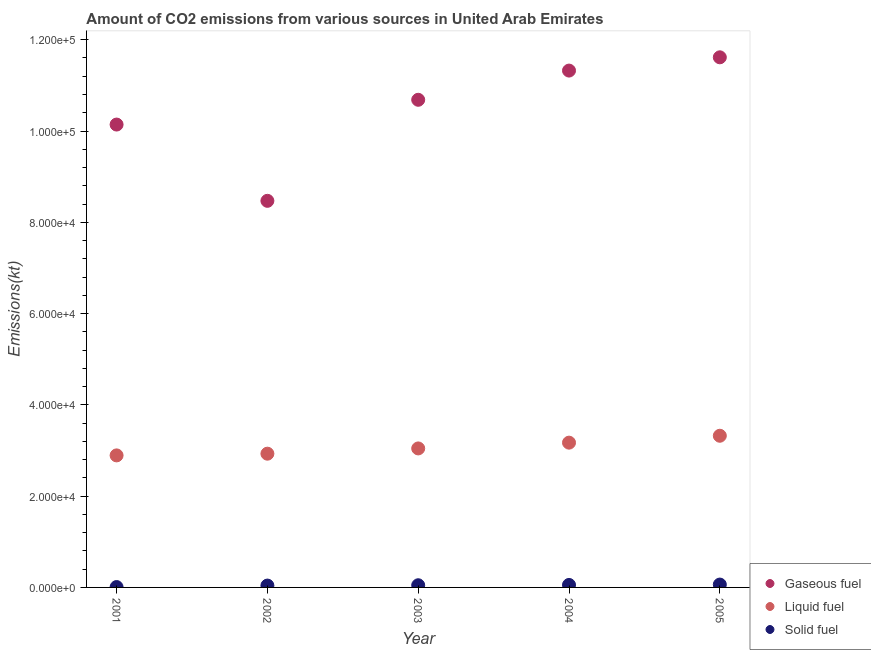What is the amount of co2 emissions from solid fuel in 2002?
Give a very brief answer. 407.04. Across all years, what is the maximum amount of co2 emissions from solid fuel?
Make the answer very short. 627.06. Across all years, what is the minimum amount of co2 emissions from liquid fuel?
Make the answer very short. 2.89e+04. What is the total amount of co2 emissions from liquid fuel in the graph?
Your answer should be very brief. 1.54e+05. What is the difference between the amount of co2 emissions from solid fuel in 2002 and that in 2004?
Make the answer very short. -135.68. What is the difference between the amount of co2 emissions from solid fuel in 2001 and the amount of co2 emissions from gaseous fuel in 2004?
Provide a succinct answer. -1.13e+05. What is the average amount of co2 emissions from liquid fuel per year?
Ensure brevity in your answer.  3.07e+04. In the year 2003, what is the difference between the amount of co2 emissions from gaseous fuel and amount of co2 emissions from liquid fuel?
Provide a short and direct response. 7.64e+04. What is the ratio of the amount of co2 emissions from gaseous fuel in 2003 to that in 2005?
Your response must be concise. 0.92. Is the amount of co2 emissions from liquid fuel in 2001 less than that in 2005?
Give a very brief answer. Yes. Is the difference between the amount of co2 emissions from gaseous fuel in 2001 and 2003 greater than the difference between the amount of co2 emissions from liquid fuel in 2001 and 2003?
Ensure brevity in your answer.  No. What is the difference between the highest and the second highest amount of co2 emissions from gaseous fuel?
Make the answer very short. 2907.93. What is the difference between the highest and the lowest amount of co2 emissions from solid fuel?
Keep it short and to the point. 546.38. In how many years, is the amount of co2 emissions from solid fuel greater than the average amount of co2 emissions from solid fuel taken over all years?
Provide a succinct answer. 3. Does the amount of co2 emissions from liquid fuel monotonically increase over the years?
Offer a terse response. Yes. Is the amount of co2 emissions from gaseous fuel strictly greater than the amount of co2 emissions from liquid fuel over the years?
Offer a very short reply. Yes. Is the amount of co2 emissions from gaseous fuel strictly less than the amount of co2 emissions from liquid fuel over the years?
Provide a short and direct response. No. What is the difference between two consecutive major ticks on the Y-axis?
Provide a succinct answer. 2.00e+04. Does the graph contain grids?
Ensure brevity in your answer.  No. Where does the legend appear in the graph?
Provide a succinct answer. Bottom right. How many legend labels are there?
Provide a succinct answer. 3. How are the legend labels stacked?
Keep it short and to the point. Vertical. What is the title of the graph?
Ensure brevity in your answer.  Amount of CO2 emissions from various sources in United Arab Emirates. Does "Natural gas sources" appear as one of the legend labels in the graph?
Give a very brief answer. No. What is the label or title of the Y-axis?
Your answer should be compact. Emissions(kt). What is the Emissions(kt) of Gaseous fuel in 2001?
Keep it short and to the point. 1.01e+05. What is the Emissions(kt) in Liquid fuel in 2001?
Your answer should be very brief. 2.89e+04. What is the Emissions(kt) of Solid fuel in 2001?
Provide a succinct answer. 80.67. What is the Emissions(kt) of Gaseous fuel in 2002?
Your answer should be compact. 8.47e+04. What is the Emissions(kt) of Liquid fuel in 2002?
Provide a succinct answer. 2.93e+04. What is the Emissions(kt) of Solid fuel in 2002?
Keep it short and to the point. 407.04. What is the Emissions(kt) of Gaseous fuel in 2003?
Offer a terse response. 1.07e+05. What is the Emissions(kt) in Liquid fuel in 2003?
Your answer should be compact. 3.05e+04. What is the Emissions(kt) in Solid fuel in 2003?
Make the answer very short. 476.71. What is the Emissions(kt) in Gaseous fuel in 2004?
Give a very brief answer. 1.13e+05. What is the Emissions(kt) in Liquid fuel in 2004?
Ensure brevity in your answer.  3.17e+04. What is the Emissions(kt) of Solid fuel in 2004?
Ensure brevity in your answer.  542.72. What is the Emissions(kt) in Gaseous fuel in 2005?
Offer a terse response. 1.16e+05. What is the Emissions(kt) of Liquid fuel in 2005?
Your answer should be very brief. 3.32e+04. What is the Emissions(kt) of Solid fuel in 2005?
Give a very brief answer. 627.06. Across all years, what is the maximum Emissions(kt) of Gaseous fuel?
Keep it short and to the point. 1.16e+05. Across all years, what is the maximum Emissions(kt) of Liquid fuel?
Your answer should be compact. 3.32e+04. Across all years, what is the maximum Emissions(kt) of Solid fuel?
Your answer should be compact. 627.06. Across all years, what is the minimum Emissions(kt) in Gaseous fuel?
Your response must be concise. 8.47e+04. Across all years, what is the minimum Emissions(kt) in Liquid fuel?
Give a very brief answer. 2.89e+04. Across all years, what is the minimum Emissions(kt) in Solid fuel?
Make the answer very short. 80.67. What is the total Emissions(kt) in Gaseous fuel in the graph?
Your answer should be compact. 5.22e+05. What is the total Emissions(kt) of Liquid fuel in the graph?
Provide a succinct answer. 1.54e+05. What is the total Emissions(kt) of Solid fuel in the graph?
Keep it short and to the point. 2134.19. What is the difference between the Emissions(kt) of Gaseous fuel in 2001 and that in 2002?
Give a very brief answer. 1.67e+04. What is the difference between the Emissions(kt) in Liquid fuel in 2001 and that in 2002?
Your response must be concise. -374.03. What is the difference between the Emissions(kt) in Solid fuel in 2001 and that in 2002?
Your response must be concise. -326.36. What is the difference between the Emissions(kt) of Gaseous fuel in 2001 and that in 2003?
Your answer should be very brief. -5427.16. What is the difference between the Emissions(kt) of Liquid fuel in 2001 and that in 2003?
Ensure brevity in your answer.  -1525.47. What is the difference between the Emissions(kt) in Solid fuel in 2001 and that in 2003?
Keep it short and to the point. -396.04. What is the difference between the Emissions(kt) of Gaseous fuel in 2001 and that in 2004?
Offer a very short reply. -1.18e+04. What is the difference between the Emissions(kt) in Liquid fuel in 2001 and that in 2004?
Your response must be concise. -2790.59. What is the difference between the Emissions(kt) in Solid fuel in 2001 and that in 2004?
Your answer should be very brief. -462.04. What is the difference between the Emissions(kt) in Gaseous fuel in 2001 and that in 2005?
Make the answer very short. -1.47e+04. What is the difference between the Emissions(kt) in Liquid fuel in 2001 and that in 2005?
Provide a succinct answer. -4301.39. What is the difference between the Emissions(kt) of Solid fuel in 2001 and that in 2005?
Your answer should be compact. -546.38. What is the difference between the Emissions(kt) of Gaseous fuel in 2002 and that in 2003?
Offer a very short reply. -2.21e+04. What is the difference between the Emissions(kt) of Liquid fuel in 2002 and that in 2003?
Your response must be concise. -1151.44. What is the difference between the Emissions(kt) of Solid fuel in 2002 and that in 2003?
Make the answer very short. -69.67. What is the difference between the Emissions(kt) of Gaseous fuel in 2002 and that in 2004?
Offer a terse response. -2.85e+04. What is the difference between the Emissions(kt) in Liquid fuel in 2002 and that in 2004?
Your response must be concise. -2416.55. What is the difference between the Emissions(kt) in Solid fuel in 2002 and that in 2004?
Offer a very short reply. -135.68. What is the difference between the Emissions(kt) of Gaseous fuel in 2002 and that in 2005?
Offer a terse response. -3.14e+04. What is the difference between the Emissions(kt) in Liquid fuel in 2002 and that in 2005?
Give a very brief answer. -3927.36. What is the difference between the Emissions(kt) in Solid fuel in 2002 and that in 2005?
Your answer should be compact. -220.02. What is the difference between the Emissions(kt) of Gaseous fuel in 2003 and that in 2004?
Keep it short and to the point. -6398.91. What is the difference between the Emissions(kt) of Liquid fuel in 2003 and that in 2004?
Provide a short and direct response. -1265.12. What is the difference between the Emissions(kt) of Solid fuel in 2003 and that in 2004?
Provide a short and direct response. -66.01. What is the difference between the Emissions(kt) in Gaseous fuel in 2003 and that in 2005?
Keep it short and to the point. -9306.85. What is the difference between the Emissions(kt) in Liquid fuel in 2003 and that in 2005?
Offer a very short reply. -2775.92. What is the difference between the Emissions(kt) of Solid fuel in 2003 and that in 2005?
Offer a very short reply. -150.35. What is the difference between the Emissions(kt) in Gaseous fuel in 2004 and that in 2005?
Ensure brevity in your answer.  -2907.93. What is the difference between the Emissions(kt) in Liquid fuel in 2004 and that in 2005?
Keep it short and to the point. -1510.8. What is the difference between the Emissions(kt) in Solid fuel in 2004 and that in 2005?
Offer a very short reply. -84.34. What is the difference between the Emissions(kt) of Gaseous fuel in 2001 and the Emissions(kt) of Liquid fuel in 2002?
Offer a very short reply. 7.21e+04. What is the difference between the Emissions(kt) of Gaseous fuel in 2001 and the Emissions(kt) of Solid fuel in 2002?
Your response must be concise. 1.01e+05. What is the difference between the Emissions(kt) in Liquid fuel in 2001 and the Emissions(kt) in Solid fuel in 2002?
Make the answer very short. 2.85e+04. What is the difference between the Emissions(kt) of Gaseous fuel in 2001 and the Emissions(kt) of Liquid fuel in 2003?
Offer a very short reply. 7.10e+04. What is the difference between the Emissions(kt) in Gaseous fuel in 2001 and the Emissions(kt) in Solid fuel in 2003?
Make the answer very short. 1.01e+05. What is the difference between the Emissions(kt) in Liquid fuel in 2001 and the Emissions(kt) in Solid fuel in 2003?
Make the answer very short. 2.85e+04. What is the difference between the Emissions(kt) in Gaseous fuel in 2001 and the Emissions(kt) in Liquid fuel in 2004?
Provide a short and direct response. 6.97e+04. What is the difference between the Emissions(kt) of Gaseous fuel in 2001 and the Emissions(kt) of Solid fuel in 2004?
Ensure brevity in your answer.  1.01e+05. What is the difference between the Emissions(kt) of Liquid fuel in 2001 and the Emissions(kt) of Solid fuel in 2004?
Make the answer very short. 2.84e+04. What is the difference between the Emissions(kt) of Gaseous fuel in 2001 and the Emissions(kt) of Liquid fuel in 2005?
Make the answer very short. 6.82e+04. What is the difference between the Emissions(kt) in Gaseous fuel in 2001 and the Emissions(kt) in Solid fuel in 2005?
Your response must be concise. 1.01e+05. What is the difference between the Emissions(kt) in Liquid fuel in 2001 and the Emissions(kt) in Solid fuel in 2005?
Your answer should be very brief. 2.83e+04. What is the difference between the Emissions(kt) of Gaseous fuel in 2002 and the Emissions(kt) of Liquid fuel in 2003?
Provide a short and direct response. 5.42e+04. What is the difference between the Emissions(kt) of Gaseous fuel in 2002 and the Emissions(kt) of Solid fuel in 2003?
Provide a succinct answer. 8.42e+04. What is the difference between the Emissions(kt) of Liquid fuel in 2002 and the Emissions(kt) of Solid fuel in 2003?
Your answer should be compact. 2.88e+04. What is the difference between the Emissions(kt) of Gaseous fuel in 2002 and the Emissions(kt) of Liquid fuel in 2004?
Keep it short and to the point. 5.30e+04. What is the difference between the Emissions(kt) of Gaseous fuel in 2002 and the Emissions(kt) of Solid fuel in 2004?
Give a very brief answer. 8.42e+04. What is the difference between the Emissions(kt) in Liquid fuel in 2002 and the Emissions(kt) in Solid fuel in 2004?
Make the answer very short. 2.88e+04. What is the difference between the Emissions(kt) in Gaseous fuel in 2002 and the Emissions(kt) in Liquid fuel in 2005?
Make the answer very short. 5.15e+04. What is the difference between the Emissions(kt) in Gaseous fuel in 2002 and the Emissions(kt) in Solid fuel in 2005?
Your answer should be very brief. 8.41e+04. What is the difference between the Emissions(kt) of Liquid fuel in 2002 and the Emissions(kt) of Solid fuel in 2005?
Your answer should be very brief. 2.87e+04. What is the difference between the Emissions(kt) in Gaseous fuel in 2003 and the Emissions(kt) in Liquid fuel in 2004?
Provide a succinct answer. 7.51e+04. What is the difference between the Emissions(kt) in Gaseous fuel in 2003 and the Emissions(kt) in Solid fuel in 2004?
Offer a terse response. 1.06e+05. What is the difference between the Emissions(kt) in Liquid fuel in 2003 and the Emissions(kt) in Solid fuel in 2004?
Give a very brief answer. 2.99e+04. What is the difference between the Emissions(kt) of Gaseous fuel in 2003 and the Emissions(kt) of Liquid fuel in 2005?
Your response must be concise. 7.36e+04. What is the difference between the Emissions(kt) in Gaseous fuel in 2003 and the Emissions(kt) in Solid fuel in 2005?
Your answer should be very brief. 1.06e+05. What is the difference between the Emissions(kt) in Liquid fuel in 2003 and the Emissions(kt) in Solid fuel in 2005?
Provide a short and direct response. 2.98e+04. What is the difference between the Emissions(kt) in Gaseous fuel in 2004 and the Emissions(kt) in Liquid fuel in 2005?
Your answer should be compact. 8.00e+04. What is the difference between the Emissions(kt) in Gaseous fuel in 2004 and the Emissions(kt) in Solid fuel in 2005?
Your answer should be compact. 1.13e+05. What is the difference between the Emissions(kt) in Liquid fuel in 2004 and the Emissions(kt) in Solid fuel in 2005?
Make the answer very short. 3.11e+04. What is the average Emissions(kt) of Gaseous fuel per year?
Your answer should be compact. 1.04e+05. What is the average Emissions(kt) in Liquid fuel per year?
Keep it short and to the point. 3.07e+04. What is the average Emissions(kt) in Solid fuel per year?
Offer a very short reply. 426.84. In the year 2001, what is the difference between the Emissions(kt) of Gaseous fuel and Emissions(kt) of Liquid fuel?
Offer a very short reply. 7.25e+04. In the year 2001, what is the difference between the Emissions(kt) in Gaseous fuel and Emissions(kt) in Solid fuel?
Give a very brief answer. 1.01e+05. In the year 2001, what is the difference between the Emissions(kt) of Liquid fuel and Emissions(kt) of Solid fuel?
Give a very brief answer. 2.88e+04. In the year 2002, what is the difference between the Emissions(kt) in Gaseous fuel and Emissions(kt) in Liquid fuel?
Your answer should be very brief. 5.54e+04. In the year 2002, what is the difference between the Emissions(kt) of Gaseous fuel and Emissions(kt) of Solid fuel?
Provide a short and direct response. 8.43e+04. In the year 2002, what is the difference between the Emissions(kt) in Liquid fuel and Emissions(kt) in Solid fuel?
Provide a short and direct response. 2.89e+04. In the year 2003, what is the difference between the Emissions(kt) in Gaseous fuel and Emissions(kt) in Liquid fuel?
Ensure brevity in your answer.  7.64e+04. In the year 2003, what is the difference between the Emissions(kt) in Gaseous fuel and Emissions(kt) in Solid fuel?
Provide a succinct answer. 1.06e+05. In the year 2003, what is the difference between the Emissions(kt) of Liquid fuel and Emissions(kt) of Solid fuel?
Keep it short and to the point. 3.00e+04. In the year 2004, what is the difference between the Emissions(kt) of Gaseous fuel and Emissions(kt) of Liquid fuel?
Provide a succinct answer. 8.15e+04. In the year 2004, what is the difference between the Emissions(kt) of Gaseous fuel and Emissions(kt) of Solid fuel?
Offer a terse response. 1.13e+05. In the year 2004, what is the difference between the Emissions(kt) of Liquid fuel and Emissions(kt) of Solid fuel?
Offer a terse response. 3.12e+04. In the year 2005, what is the difference between the Emissions(kt) in Gaseous fuel and Emissions(kt) in Liquid fuel?
Offer a very short reply. 8.29e+04. In the year 2005, what is the difference between the Emissions(kt) in Gaseous fuel and Emissions(kt) in Solid fuel?
Offer a terse response. 1.16e+05. In the year 2005, what is the difference between the Emissions(kt) in Liquid fuel and Emissions(kt) in Solid fuel?
Offer a terse response. 3.26e+04. What is the ratio of the Emissions(kt) in Gaseous fuel in 2001 to that in 2002?
Offer a terse response. 1.2. What is the ratio of the Emissions(kt) in Liquid fuel in 2001 to that in 2002?
Provide a succinct answer. 0.99. What is the ratio of the Emissions(kt) in Solid fuel in 2001 to that in 2002?
Provide a short and direct response. 0.2. What is the ratio of the Emissions(kt) of Gaseous fuel in 2001 to that in 2003?
Your response must be concise. 0.95. What is the ratio of the Emissions(kt) of Liquid fuel in 2001 to that in 2003?
Your response must be concise. 0.95. What is the ratio of the Emissions(kt) of Solid fuel in 2001 to that in 2003?
Your answer should be compact. 0.17. What is the ratio of the Emissions(kt) in Gaseous fuel in 2001 to that in 2004?
Your response must be concise. 0.9. What is the ratio of the Emissions(kt) of Liquid fuel in 2001 to that in 2004?
Your response must be concise. 0.91. What is the ratio of the Emissions(kt) in Solid fuel in 2001 to that in 2004?
Your answer should be compact. 0.15. What is the ratio of the Emissions(kt) in Gaseous fuel in 2001 to that in 2005?
Give a very brief answer. 0.87. What is the ratio of the Emissions(kt) of Liquid fuel in 2001 to that in 2005?
Provide a succinct answer. 0.87. What is the ratio of the Emissions(kt) in Solid fuel in 2001 to that in 2005?
Provide a short and direct response. 0.13. What is the ratio of the Emissions(kt) of Gaseous fuel in 2002 to that in 2003?
Your response must be concise. 0.79. What is the ratio of the Emissions(kt) in Liquid fuel in 2002 to that in 2003?
Provide a succinct answer. 0.96. What is the ratio of the Emissions(kt) of Solid fuel in 2002 to that in 2003?
Your response must be concise. 0.85. What is the ratio of the Emissions(kt) in Gaseous fuel in 2002 to that in 2004?
Offer a very short reply. 0.75. What is the ratio of the Emissions(kt) in Liquid fuel in 2002 to that in 2004?
Ensure brevity in your answer.  0.92. What is the ratio of the Emissions(kt) in Solid fuel in 2002 to that in 2004?
Provide a short and direct response. 0.75. What is the ratio of the Emissions(kt) of Gaseous fuel in 2002 to that in 2005?
Your response must be concise. 0.73. What is the ratio of the Emissions(kt) of Liquid fuel in 2002 to that in 2005?
Offer a very short reply. 0.88. What is the ratio of the Emissions(kt) of Solid fuel in 2002 to that in 2005?
Your response must be concise. 0.65. What is the ratio of the Emissions(kt) of Gaseous fuel in 2003 to that in 2004?
Offer a very short reply. 0.94. What is the ratio of the Emissions(kt) in Liquid fuel in 2003 to that in 2004?
Provide a succinct answer. 0.96. What is the ratio of the Emissions(kt) of Solid fuel in 2003 to that in 2004?
Your answer should be compact. 0.88. What is the ratio of the Emissions(kt) in Gaseous fuel in 2003 to that in 2005?
Provide a short and direct response. 0.92. What is the ratio of the Emissions(kt) in Liquid fuel in 2003 to that in 2005?
Make the answer very short. 0.92. What is the ratio of the Emissions(kt) in Solid fuel in 2003 to that in 2005?
Offer a terse response. 0.76. What is the ratio of the Emissions(kt) of Gaseous fuel in 2004 to that in 2005?
Your answer should be very brief. 0.97. What is the ratio of the Emissions(kt) of Liquid fuel in 2004 to that in 2005?
Make the answer very short. 0.95. What is the ratio of the Emissions(kt) in Solid fuel in 2004 to that in 2005?
Offer a very short reply. 0.87. What is the difference between the highest and the second highest Emissions(kt) of Gaseous fuel?
Offer a very short reply. 2907.93. What is the difference between the highest and the second highest Emissions(kt) in Liquid fuel?
Your response must be concise. 1510.8. What is the difference between the highest and the second highest Emissions(kt) of Solid fuel?
Keep it short and to the point. 84.34. What is the difference between the highest and the lowest Emissions(kt) in Gaseous fuel?
Your response must be concise. 3.14e+04. What is the difference between the highest and the lowest Emissions(kt) of Liquid fuel?
Offer a very short reply. 4301.39. What is the difference between the highest and the lowest Emissions(kt) in Solid fuel?
Make the answer very short. 546.38. 